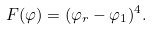Convert formula to latex. <formula><loc_0><loc_0><loc_500><loc_500>F ( \varphi ) = ( \varphi _ { r } - \varphi _ { 1 } ) ^ { 4 } .</formula> 